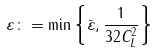Convert formula to latex. <formula><loc_0><loc_0><loc_500><loc_500>\varepsilon \colon = \min \left \{ \bar { \varepsilon } , \frac { 1 } { 3 2 C _ { L } ^ { 2 } } \right \}</formula> 